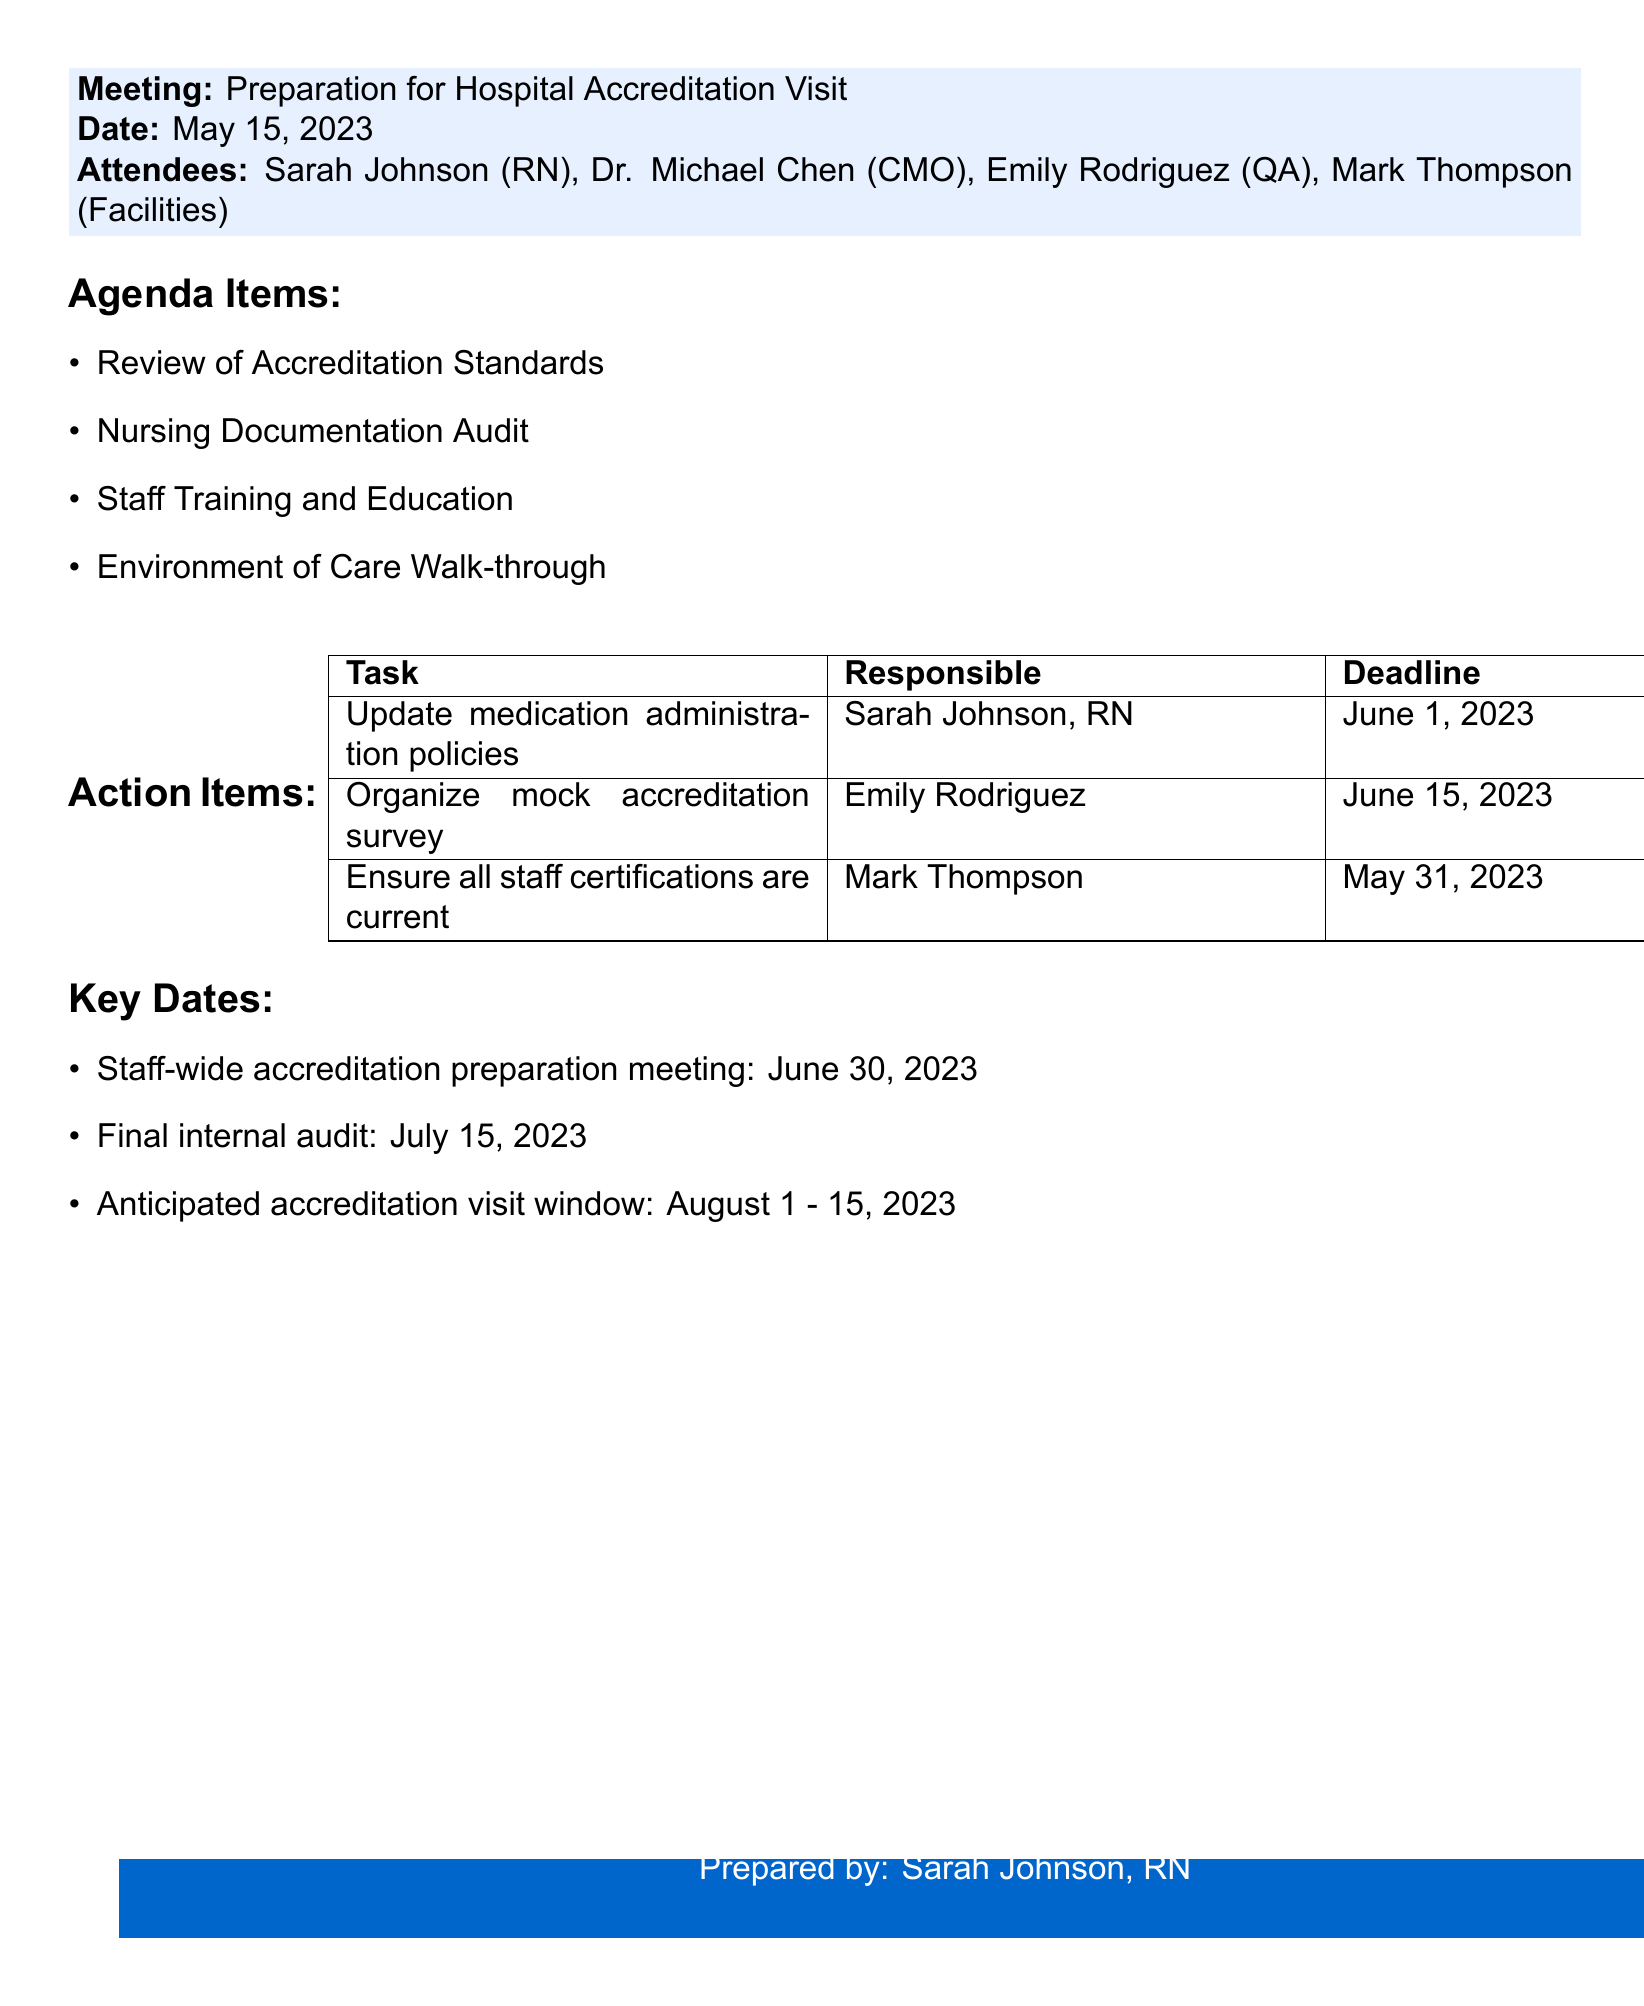What is the date of the meeting? The date of the meeting is explicitly stated in the document as May 15, 2023.
Answer: May 15, 2023 Who is responsible for updating medication administration policies? The document specifies that Sarah Johnson, RN is responsible for this task.
Answer: Sarah Johnson, RN What is the deadline for ensuring all staff certifications are current? The deadline is provided in the action items section as May 31, 2023.
Answer: May 31, 2023 When is the anticipated accreditation visit window? This range is directly mentioned in the key dates section as August 1 to August 15, 2023.
Answer: August 1 to August 15, 2023 What is one of the agenda items discussed during the meeting? The agenda items listed include a variety of topics; one of them is "Nursing Documentation Audit."
Answer: Nursing Documentation Audit How many action items are recorded in the meeting minutes? The document lists a total of three action items under the Action Items section.
Answer: Three What is the event scheduled for June 30, 2023? This date is mentioned as the staff-wide accreditation preparation meeting in the key dates section.
Answer: Staff-wide accreditation preparation meeting Which attendee is the Facilities Director? The document identifies Mark Thompson as the individual in this role.
Answer: Mark Thompson 